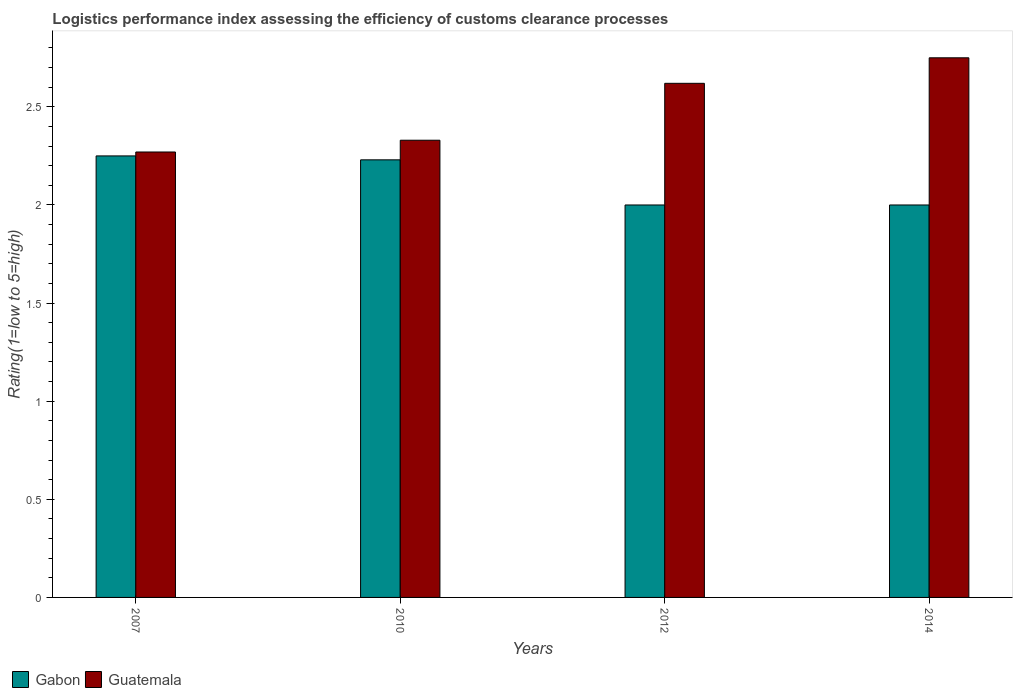How many different coloured bars are there?
Keep it short and to the point. 2. How many groups of bars are there?
Keep it short and to the point. 4. How many bars are there on the 4th tick from the left?
Ensure brevity in your answer.  2. How many bars are there on the 1st tick from the right?
Give a very brief answer. 2. In how many cases, is the number of bars for a given year not equal to the number of legend labels?
Offer a terse response. 0. What is the Logistic performance index in Gabon in 2007?
Give a very brief answer. 2.25. Across all years, what is the maximum Logistic performance index in Gabon?
Your response must be concise. 2.25. Across all years, what is the minimum Logistic performance index in Guatemala?
Offer a terse response. 2.27. In which year was the Logistic performance index in Guatemala maximum?
Keep it short and to the point. 2014. In which year was the Logistic performance index in Guatemala minimum?
Offer a terse response. 2007. What is the total Logistic performance index in Guatemala in the graph?
Offer a very short reply. 9.97. What is the difference between the Logistic performance index in Guatemala in 2010 and that in 2014?
Give a very brief answer. -0.42. What is the difference between the Logistic performance index in Gabon in 2010 and the Logistic performance index in Guatemala in 2012?
Give a very brief answer. -0.39. What is the average Logistic performance index in Guatemala per year?
Offer a terse response. 2.49. In the year 2010, what is the difference between the Logistic performance index in Gabon and Logistic performance index in Guatemala?
Offer a terse response. -0.1. In how many years, is the Logistic performance index in Gabon greater than 1.1?
Offer a terse response. 4. What is the ratio of the Logistic performance index in Gabon in 2010 to that in 2014?
Ensure brevity in your answer.  1.11. Is the Logistic performance index in Guatemala in 2010 less than that in 2012?
Make the answer very short. Yes. Is the difference between the Logistic performance index in Gabon in 2010 and 2014 greater than the difference between the Logistic performance index in Guatemala in 2010 and 2014?
Your answer should be compact. Yes. What is the difference between the highest and the second highest Logistic performance index in Gabon?
Your answer should be very brief. 0.02. What is the difference between the highest and the lowest Logistic performance index in Guatemala?
Provide a succinct answer. 0.48. In how many years, is the Logistic performance index in Guatemala greater than the average Logistic performance index in Guatemala taken over all years?
Offer a very short reply. 2. What does the 2nd bar from the left in 2010 represents?
Offer a terse response. Guatemala. What does the 2nd bar from the right in 2012 represents?
Make the answer very short. Gabon. How many bars are there?
Give a very brief answer. 8. Are all the bars in the graph horizontal?
Make the answer very short. No. Are the values on the major ticks of Y-axis written in scientific E-notation?
Your response must be concise. No. Does the graph contain any zero values?
Your answer should be very brief. No. How many legend labels are there?
Your answer should be compact. 2. How are the legend labels stacked?
Offer a terse response. Horizontal. What is the title of the graph?
Keep it short and to the point. Logistics performance index assessing the efficiency of customs clearance processes. What is the label or title of the X-axis?
Provide a short and direct response. Years. What is the label or title of the Y-axis?
Keep it short and to the point. Rating(1=low to 5=high). What is the Rating(1=low to 5=high) in Gabon in 2007?
Make the answer very short. 2.25. What is the Rating(1=low to 5=high) in Guatemala in 2007?
Your response must be concise. 2.27. What is the Rating(1=low to 5=high) of Gabon in 2010?
Your response must be concise. 2.23. What is the Rating(1=low to 5=high) of Guatemala in 2010?
Your answer should be very brief. 2.33. What is the Rating(1=low to 5=high) in Gabon in 2012?
Ensure brevity in your answer.  2. What is the Rating(1=low to 5=high) in Guatemala in 2012?
Offer a terse response. 2.62. What is the Rating(1=low to 5=high) of Gabon in 2014?
Provide a succinct answer. 2. What is the Rating(1=low to 5=high) of Guatemala in 2014?
Give a very brief answer. 2.75. Across all years, what is the maximum Rating(1=low to 5=high) in Gabon?
Your answer should be very brief. 2.25. Across all years, what is the maximum Rating(1=low to 5=high) in Guatemala?
Offer a very short reply. 2.75. Across all years, what is the minimum Rating(1=low to 5=high) in Gabon?
Provide a short and direct response. 2. Across all years, what is the minimum Rating(1=low to 5=high) of Guatemala?
Your answer should be compact. 2.27. What is the total Rating(1=low to 5=high) in Gabon in the graph?
Keep it short and to the point. 8.48. What is the total Rating(1=low to 5=high) of Guatemala in the graph?
Provide a succinct answer. 9.97. What is the difference between the Rating(1=low to 5=high) of Guatemala in 2007 and that in 2010?
Your answer should be very brief. -0.06. What is the difference between the Rating(1=low to 5=high) of Guatemala in 2007 and that in 2012?
Your response must be concise. -0.35. What is the difference between the Rating(1=low to 5=high) of Guatemala in 2007 and that in 2014?
Ensure brevity in your answer.  -0.48. What is the difference between the Rating(1=low to 5=high) in Gabon in 2010 and that in 2012?
Offer a terse response. 0.23. What is the difference between the Rating(1=low to 5=high) of Guatemala in 2010 and that in 2012?
Offer a terse response. -0.29. What is the difference between the Rating(1=low to 5=high) in Gabon in 2010 and that in 2014?
Keep it short and to the point. 0.23. What is the difference between the Rating(1=low to 5=high) of Guatemala in 2010 and that in 2014?
Your answer should be very brief. -0.42. What is the difference between the Rating(1=low to 5=high) in Gabon in 2012 and that in 2014?
Ensure brevity in your answer.  0. What is the difference between the Rating(1=low to 5=high) of Guatemala in 2012 and that in 2014?
Offer a very short reply. -0.13. What is the difference between the Rating(1=low to 5=high) of Gabon in 2007 and the Rating(1=low to 5=high) of Guatemala in 2010?
Offer a terse response. -0.08. What is the difference between the Rating(1=low to 5=high) in Gabon in 2007 and the Rating(1=low to 5=high) in Guatemala in 2012?
Your response must be concise. -0.37. What is the difference between the Rating(1=low to 5=high) of Gabon in 2007 and the Rating(1=low to 5=high) of Guatemala in 2014?
Your answer should be compact. -0.5. What is the difference between the Rating(1=low to 5=high) in Gabon in 2010 and the Rating(1=low to 5=high) in Guatemala in 2012?
Your response must be concise. -0.39. What is the difference between the Rating(1=low to 5=high) of Gabon in 2010 and the Rating(1=low to 5=high) of Guatemala in 2014?
Make the answer very short. -0.52. What is the difference between the Rating(1=low to 5=high) of Gabon in 2012 and the Rating(1=low to 5=high) of Guatemala in 2014?
Your answer should be very brief. -0.75. What is the average Rating(1=low to 5=high) in Gabon per year?
Provide a succinct answer. 2.12. What is the average Rating(1=low to 5=high) in Guatemala per year?
Offer a terse response. 2.49. In the year 2007, what is the difference between the Rating(1=low to 5=high) in Gabon and Rating(1=low to 5=high) in Guatemala?
Give a very brief answer. -0.02. In the year 2010, what is the difference between the Rating(1=low to 5=high) in Gabon and Rating(1=low to 5=high) in Guatemala?
Offer a very short reply. -0.1. In the year 2012, what is the difference between the Rating(1=low to 5=high) of Gabon and Rating(1=low to 5=high) of Guatemala?
Ensure brevity in your answer.  -0.62. In the year 2014, what is the difference between the Rating(1=low to 5=high) of Gabon and Rating(1=low to 5=high) of Guatemala?
Your answer should be compact. -0.75. What is the ratio of the Rating(1=low to 5=high) in Gabon in 2007 to that in 2010?
Give a very brief answer. 1.01. What is the ratio of the Rating(1=low to 5=high) of Guatemala in 2007 to that in 2010?
Your answer should be very brief. 0.97. What is the ratio of the Rating(1=low to 5=high) of Gabon in 2007 to that in 2012?
Give a very brief answer. 1.12. What is the ratio of the Rating(1=low to 5=high) in Guatemala in 2007 to that in 2012?
Your answer should be compact. 0.87. What is the ratio of the Rating(1=low to 5=high) of Gabon in 2007 to that in 2014?
Offer a terse response. 1.12. What is the ratio of the Rating(1=low to 5=high) of Guatemala in 2007 to that in 2014?
Keep it short and to the point. 0.83. What is the ratio of the Rating(1=low to 5=high) in Gabon in 2010 to that in 2012?
Give a very brief answer. 1.11. What is the ratio of the Rating(1=low to 5=high) of Guatemala in 2010 to that in 2012?
Ensure brevity in your answer.  0.89. What is the ratio of the Rating(1=low to 5=high) in Gabon in 2010 to that in 2014?
Ensure brevity in your answer.  1.11. What is the ratio of the Rating(1=low to 5=high) in Guatemala in 2010 to that in 2014?
Offer a very short reply. 0.85. What is the ratio of the Rating(1=low to 5=high) of Guatemala in 2012 to that in 2014?
Provide a succinct answer. 0.95. What is the difference between the highest and the second highest Rating(1=low to 5=high) in Guatemala?
Provide a short and direct response. 0.13. What is the difference between the highest and the lowest Rating(1=low to 5=high) in Gabon?
Give a very brief answer. 0.25. What is the difference between the highest and the lowest Rating(1=low to 5=high) of Guatemala?
Your answer should be very brief. 0.48. 